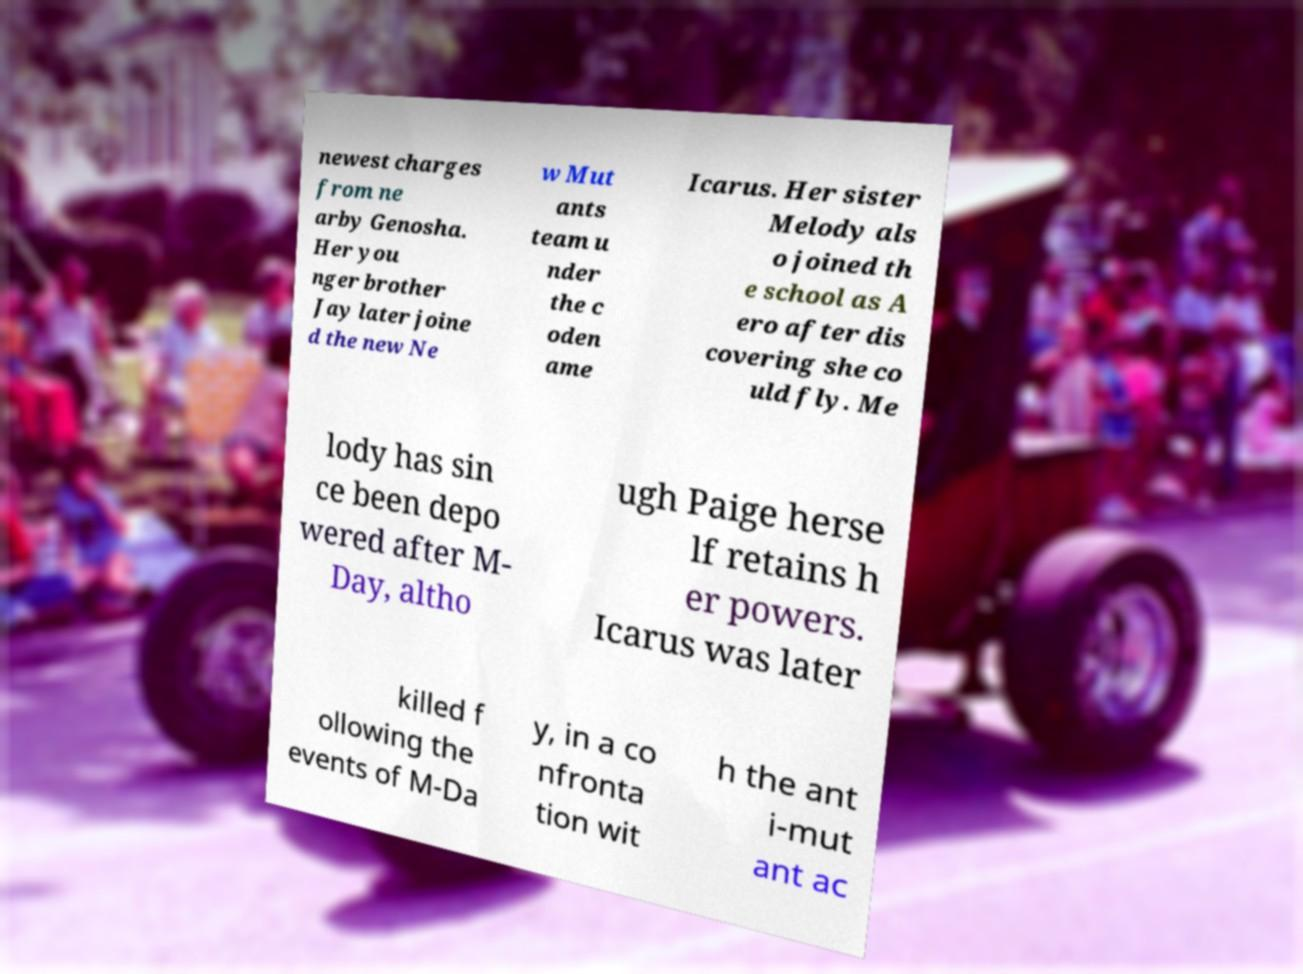Could you extract and type out the text from this image? newest charges from ne arby Genosha. Her you nger brother Jay later joine d the new Ne w Mut ants team u nder the c oden ame Icarus. Her sister Melody als o joined th e school as A ero after dis covering she co uld fly. Me lody has sin ce been depo wered after M- Day, altho ugh Paige herse lf retains h er powers. Icarus was later killed f ollowing the events of M-Da y, in a co nfronta tion wit h the ant i-mut ant ac 